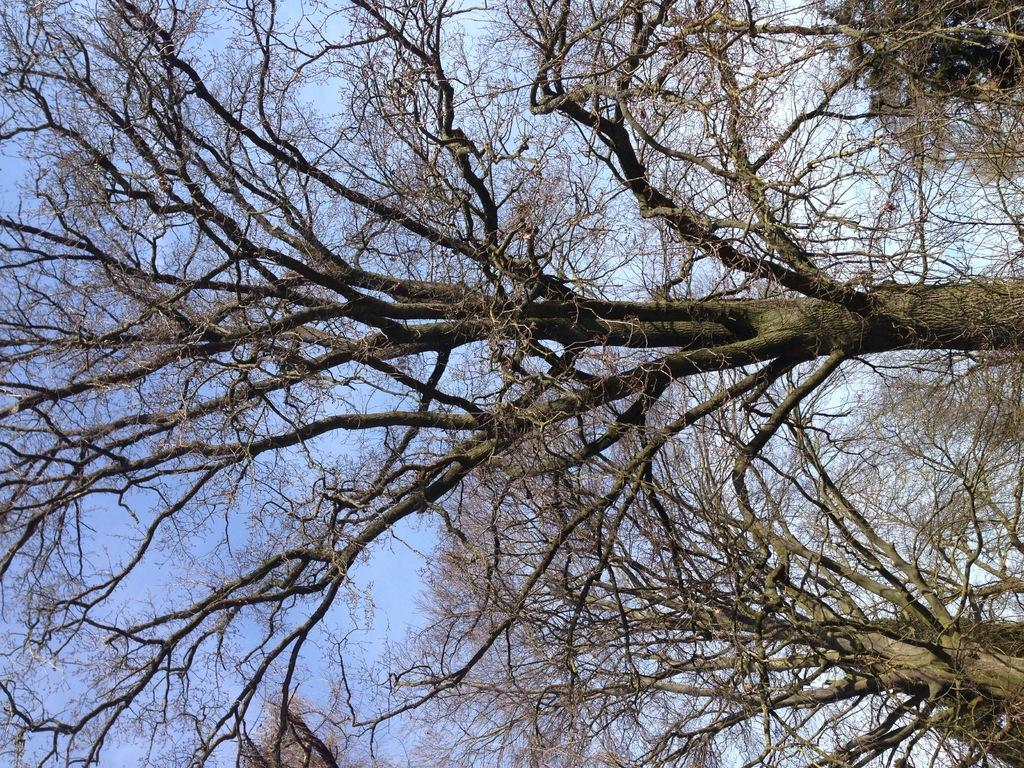What type of vegetation can be seen in the image? There are trees in the image. What part of the natural environment is visible in the image? The sky is visible in the background of the image. Can you find the receipt for the ocean in the image? There is no ocean or receipt present in the image. 